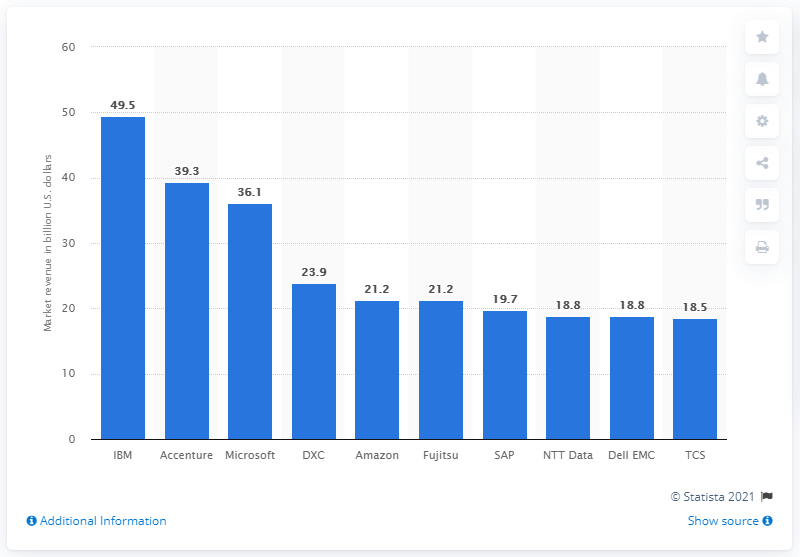Specify some key components in this picture. According to the available data, IBM was the leading vendor in the global IT service market. 